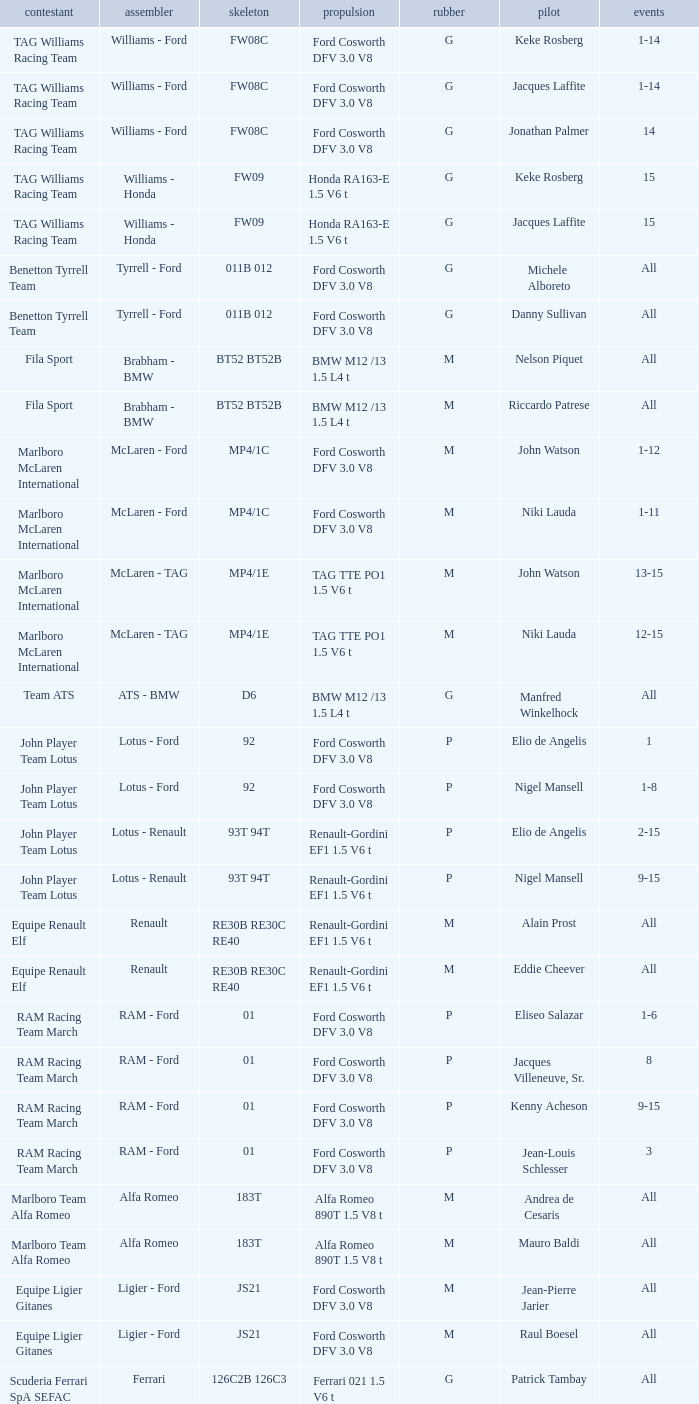Who is the Constructor for driver Piercarlo Ghinzani and a Ford cosworth dfv 3.0 v8 engine? Osella - Ford. 